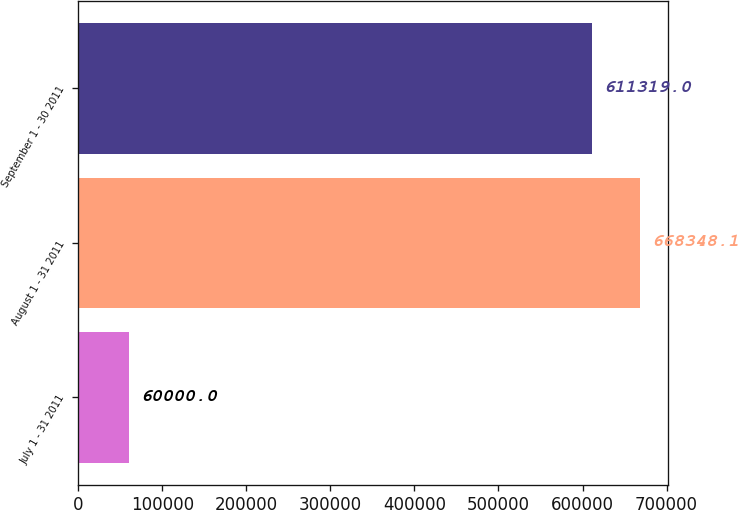Convert chart to OTSL. <chart><loc_0><loc_0><loc_500><loc_500><bar_chart><fcel>July 1 - 31 2011<fcel>August 1 - 31 2011<fcel>September 1 - 30 2011<nl><fcel>60000<fcel>668348<fcel>611319<nl></chart> 